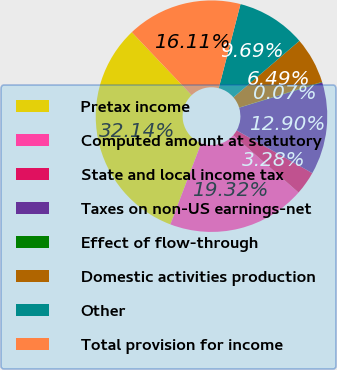<chart> <loc_0><loc_0><loc_500><loc_500><pie_chart><fcel>Pretax income<fcel>Computed amount at statutory<fcel>State and local income tax<fcel>Taxes on non-US earnings-net<fcel>Effect of flow-through<fcel>Domestic activities production<fcel>Other<fcel>Total provision for income<nl><fcel>32.14%<fcel>19.32%<fcel>3.28%<fcel>12.9%<fcel>0.07%<fcel>6.49%<fcel>9.69%<fcel>16.11%<nl></chart> 